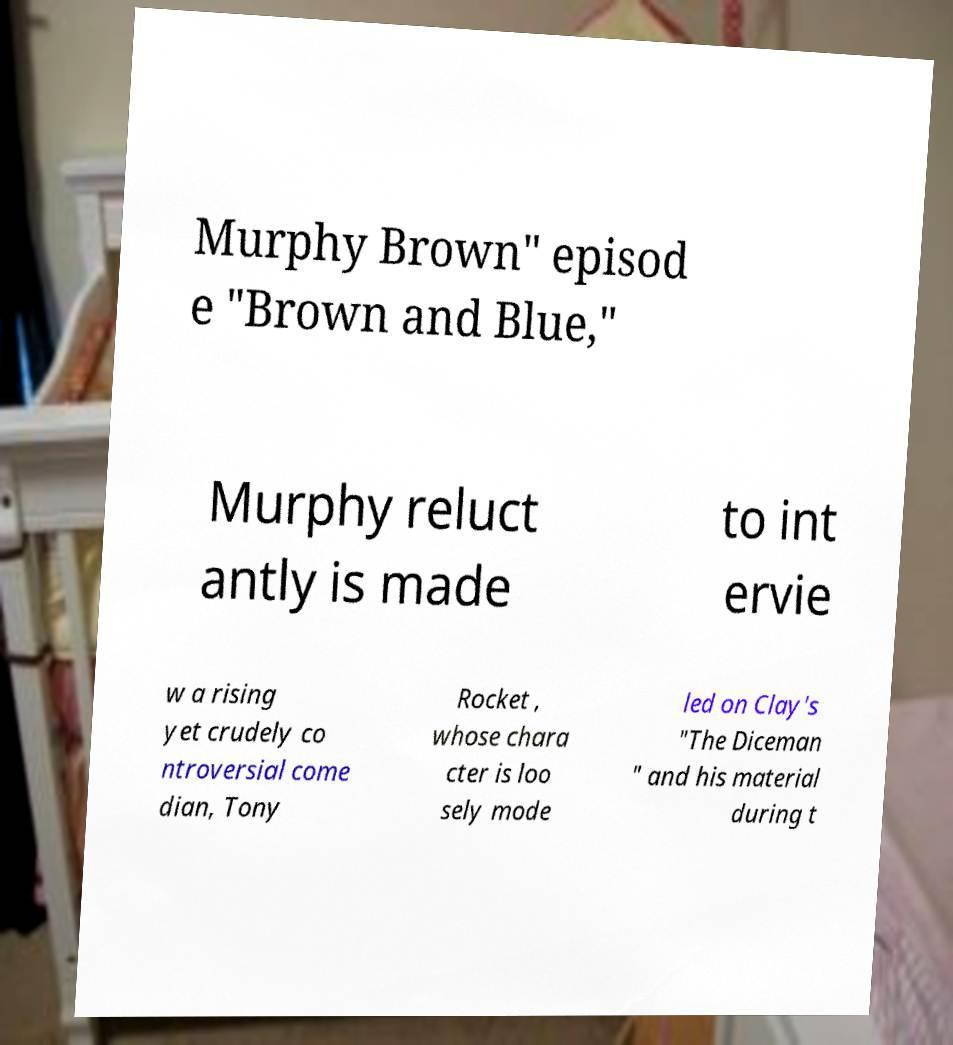Please read and relay the text visible in this image. What does it say? Murphy Brown" episod e "Brown and Blue," Murphy reluct antly is made to int ervie w a rising yet crudely co ntroversial come dian, Tony Rocket , whose chara cter is loo sely mode led on Clay's "The Diceman " and his material during t 